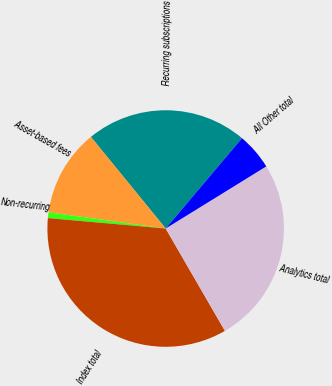Convert chart to OTSL. <chart><loc_0><loc_0><loc_500><loc_500><pie_chart><fcel>Recurring subscriptions<fcel>Asset-based fees<fcel>Non-recurring<fcel>Index total<fcel>Analytics total<fcel>All Other total<nl><fcel>22.06%<fcel>11.91%<fcel>0.79%<fcel>34.76%<fcel>25.45%<fcel>5.03%<nl></chart> 